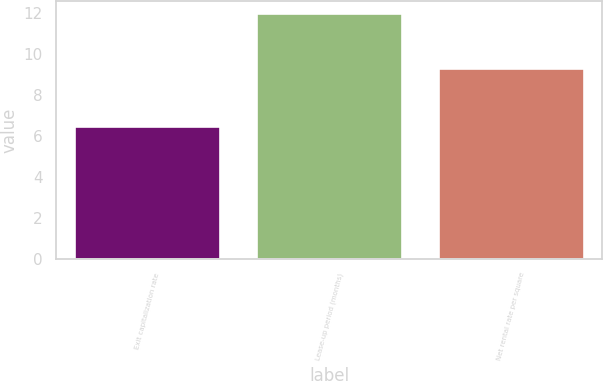<chart> <loc_0><loc_0><loc_500><loc_500><bar_chart><fcel>Exit capitalization rate<fcel>Lease-up period (months)<fcel>Net rental rate per square<nl><fcel>6.5<fcel>12<fcel>9.34<nl></chart> 